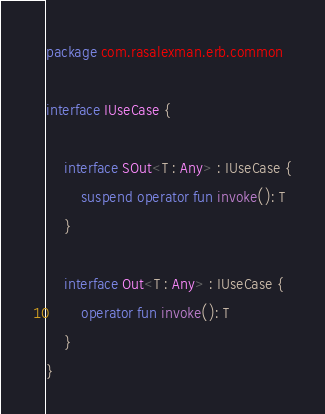<code> <loc_0><loc_0><loc_500><loc_500><_Kotlin_>package com.rasalexman.erb.common

interface IUseCase {

    interface SOut<T : Any> : IUseCase {
        suspend operator fun invoke(): T
    }

    interface Out<T : Any> : IUseCase {
        operator fun invoke(): T
    }
}</code> 